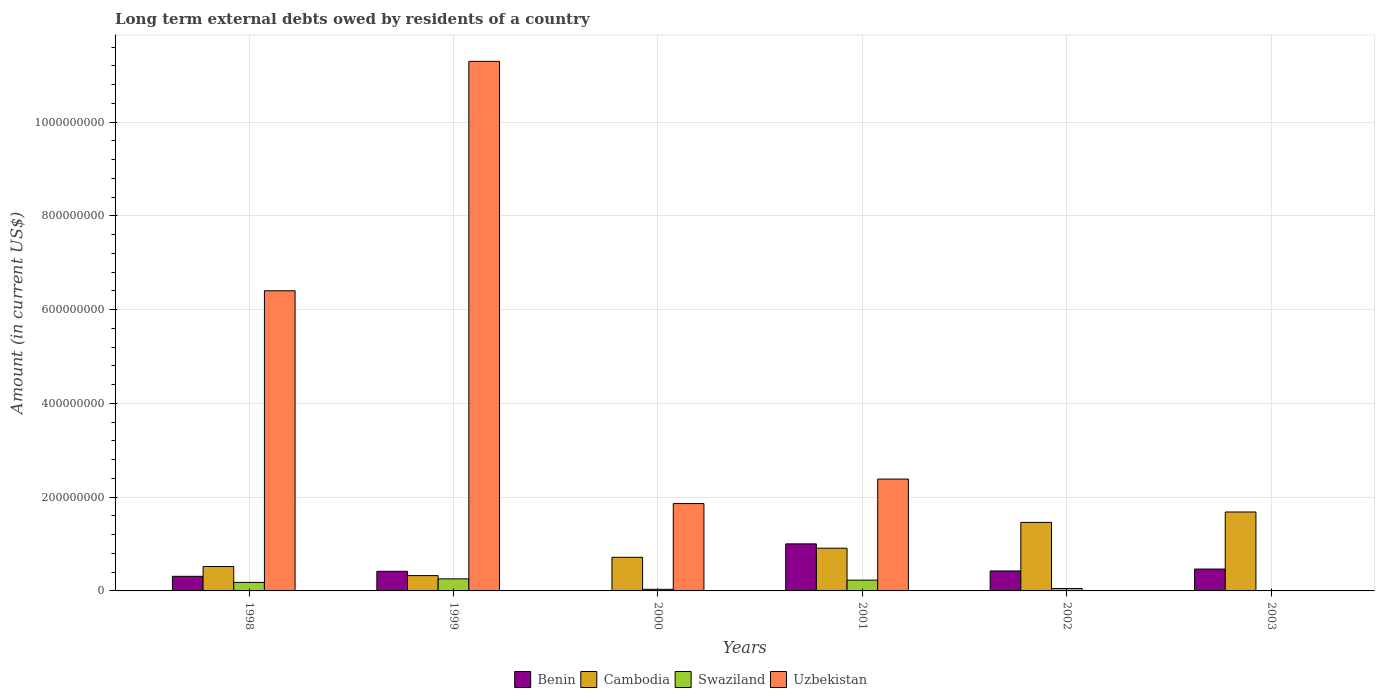How many bars are there on the 3rd tick from the right?
Make the answer very short. 4. What is the label of the 6th group of bars from the left?
Your response must be concise. 2003. Across all years, what is the maximum amount of long-term external debts owed by residents in Uzbekistan?
Your answer should be very brief. 1.13e+09. In which year was the amount of long-term external debts owed by residents in Swaziland maximum?
Your answer should be very brief. 1999. What is the total amount of long-term external debts owed by residents in Benin in the graph?
Offer a terse response. 2.63e+08. What is the difference between the amount of long-term external debts owed by residents in Swaziland in 1999 and that in 2001?
Offer a very short reply. 2.69e+06. What is the difference between the amount of long-term external debts owed by residents in Cambodia in 2000 and the amount of long-term external debts owed by residents in Swaziland in 1998?
Provide a short and direct response. 5.35e+07. What is the average amount of long-term external debts owed by residents in Swaziland per year?
Give a very brief answer. 1.26e+07. In the year 2001, what is the difference between the amount of long-term external debts owed by residents in Swaziland and amount of long-term external debts owed by residents in Benin?
Provide a succinct answer. -7.73e+07. What is the ratio of the amount of long-term external debts owed by residents in Benin in 2001 to that in 2003?
Your answer should be compact. 2.15. Is the difference between the amount of long-term external debts owed by residents in Swaziland in 1998 and 1999 greater than the difference between the amount of long-term external debts owed by residents in Benin in 1998 and 1999?
Keep it short and to the point. Yes. What is the difference between the highest and the second highest amount of long-term external debts owed by residents in Swaziland?
Ensure brevity in your answer.  2.69e+06. What is the difference between the highest and the lowest amount of long-term external debts owed by residents in Cambodia?
Give a very brief answer. 1.36e+08. Is it the case that in every year, the sum of the amount of long-term external debts owed by residents in Benin and amount of long-term external debts owed by residents in Uzbekistan is greater than the sum of amount of long-term external debts owed by residents in Cambodia and amount of long-term external debts owed by residents in Swaziland?
Keep it short and to the point. No. How many years are there in the graph?
Offer a terse response. 6. What is the difference between two consecutive major ticks on the Y-axis?
Ensure brevity in your answer.  2.00e+08. Does the graph contain grids?
Your answer should be very brief. Yes. Where does the legend appear in the graph?
Give a very brief answer. Bottom center. What is the title of the graph?
Offer a terse response. Long term external debts owed by residents of a country. What is the label or title of the X-axis?
Provide a succinct answer. Years. What is the label or title of the Y-axis?
Provide a short and direct response. Amount (in current US$). What is the Amount (in current US$) in Benin in 1998?
Make the answer very short. 3.11e+07. What is the Amount (in current US$) in Cambodia in 1998?
Your response must be concise. 5.20e+07. What is the Amount (in current US$) in Swaziland in 1998?
Provide a succinct answer. 1.82e+07. What is the Amount (in current US$) of Uzbekistan in 1998?
Your answer should be compact. 6.40e+08. What is the Amount (in current US$) of Benin in 1999?
Offer a very short reply. 4.18e+07. What is the Amount (in current US$) in Cambodia in 1999?
Your response must be concise. 3.27e+07. What is the Amount (in current US$) in Swaziland in 1999?
Ensure brevity in your answer.  2.57e+07. What is the Amount (in current US$) in Uzbekistan in 1999?
Keep it short and to the point. 1.13e+09. What is the Amount (in current US$) of Benin in 2000?
Your answer should be compact. 0. What is the Amount (in current US$) of Cambodia in 2000?
Give a very brief answer. 7.17e+07. What is the Amount (in current US$) in Swaziland in 2000?
Your response must be concise. 3.44e+06. What is the Amount (in current US$) in Uzbekistan in 2000?
Ensure brevity in your answer.  1.86e+08. What is the Amount (in current US$) in Benin in 2001?
Ensure brevity in your answer.  1.00e+08. What is the Amount (in current US$) in Cambodia in 2001?
Offer a terse response. 9.11e+07. What is the Amount (in current US$) of Swaziland in 2001?
Your answer should be compact. 2.30e+07. What is the Amount (in current US$) of Uzbekistan in 2001?
Provide a short and direct response. 2.39e+08. What is the Amount (in current US$) in Benin in 2002?
Your answer should be compact. 4.26e+07. What is the Amount (in current US$) in Cambodia in 2002?
Give a very brief answer. 1.46e+08. What is the Amount (in current US$) in Swaziland in 2002?
Your response must be concise. 5.19e+06. What is the Amount (in current US$) in Uzbekistan in 2002?
Provide a succinct answer. 0. What is the Amount (in current US$) of Benin in 2003?
Offer a very short reply. 4.66e+07. What is the Amount (in current US$) in Cambodia in 2003?
Ensure brevity in your answer.  1.68e+08. What is the Amount (in current US$) in Uzbekistan in 2003?
Offer a very short reply. 0. Across all years, what is the maximum Amount (in current US$) of Benin?
Offer a very short reply. 1.00e+08. Across all years, what is the maximum Amount (in current US$) in Cambodia?
Your answer should be compact. 1.68e+08. Across all years, what is the maximum Amount (in current US$) in Swaziland?
Offer a terse response. 2.57e+07. Across all years, what is the maximum Amount (in current US$) in Uzbekistan?
Offer a terse response. 1.13e+09. Across all years, what is the minimum Amount (in current US$) in Benin?
Your answer should be very brief. 0. Across all years, what is the minimum Amount (in current US$) of Cambodia?
Provide a succinct answer. 3.27e+07. Across all years, what is the minimum Amount (in current US$) of Uzbekistan?
Your answer should be compact. 0. What is the total Amount (in current US$) of Benin in the graph?
Provide a succinct answer. 2.63e+08. What is the total Amount (in current US$) of Cambodia in the graph?
Keep it short and to the point. 5.62e+08. What is the total Amount (in current US$) in Swaziland in the graph?
Provide a succinct answer. 7.56e+07. What is the total Amount (in current US$) of Uzbekistan in the graph?
Keep it short and to the point. 2.19e+09. What is the difference between the Amount (in current US$) of Benin in 1998 and that in 1999?
Ensure brevity in your answer.  -1.07e+07. What is the difference between the Amount (in current US$) in Cambodia in 1998 and that in 1999?
Offer a very short reply. 1.94e+07. What is the difference between the Amount (in current US$) of Swaziland in 1998 and that in 1999?
Your response must be concise. -7.54e+06. What is the difference between the Amount (in current US$) in Uzbekistan in 1998 and that in 1999?
Offer a very short reply. -4.89e+08. What is the difference between the Amount (in current US$) in Cambodia in 1998 and that in 2000?
Make the answer very short. -1.97e+07. What is the difference between the Amount (in current US$) of Swaziland in 1998 and that in 2000?
Give a very brief answer. 1.48e+07. What is the difference between the Amount (in current US$) in Uzbekistan in 1998 and that in 2000?
Make the answer very short. 4.54e+08. What is the difference between the Amount (in current US$) of Benin in 1998 and that in 2001?
Your answer should be very brief. -6.92e+07. What is the difference between the Amount (in current US$) of Cambodia in 1998 and that in 2001?
Your answer should be compact. -3.91e+07. What is the difference between the Amount (in current US$) of Swaziland in 1998 and that in 2001?
Offer a very short reply. -4.84e+06. What is the difference between the Amount (in current US$) in Uzbekistan in 1998 and that in 2001?
Offer a terse response. 4.02e+08. What is the difference between the Amount (in current US$) in Benin in 1998 and that in 2002?
Provide a short and direct response. -1.15e+07. What is the difference between the Amount (in current US$) in Cambodia in 1998 and that in 2002?
Provide a succinct answer. -9.41e+07. What is the difference between the Amount (in current US$) in Swaziland in 1998 and that in 2002?
Your answer should be very brief. 1.30e+07. What is the difference between the Amount (in current US$) in Benin in 1998 and that in 2003?
Keep it short and to the point. -1.55e+07. What is the difference between the Amount (in current US$) of Cambodia in 1998 and that in 2003?
Provide a short and direct response. -1.16e+08. What is the difference between the Amount (in current US$) of Cambodia in 1999 and that in 2000?
Provide a succinct answer. -3.91e+07. What is the difference between the Amount (in current US$) of Swaziland in 1999 and that in 2000?
Make the answer very short. 2.23e+07. What is the difference between the Amount (in current US$) in Uzbekistan in 1999 and that in 2000?
Ensure brevity in your answer.  9.43e+08. What is the difference between the Amount (in current US$) in Benin in 1999 and that in 2001?
Give a very brief answer. -5.86e+07. What is the difference between the Amount (in current US$) of Cambodia in 1999 and that in 2001?
Make the answer very short. -5.85e+07. What is the difference between the Amount (in current US$) of Swaziland in 1999 and that in 2001?
Your response must be concise. 2.69e+06. What is the difference between the Amount (in current US$) in Uzbekistan in 1999 and that in 2001?
Keep it short and to the point. 8.91e+08. What is the difference between the Amount (in current US$) of Benin in 1999 and that in 2002?
Keep it short and to the point. -8.07e+05. What is the difference between the Amount (in current US$) of Cambodia in 1999 and that in 2002?
Provide a short and direct response. -1.13e+08. What is the difference between the Amount (in current US$) of Swaziland in 1999 and that in 2002?
Provide a succinct answer. 2.06e+07. What is the difference between the Amount (in current US$) of Benin in 1999 and that in 2003?
Provide a short and direct response. -4.83e+06. What is the difference between the Amount (in current US$) in Cambodia in 1999 and that in 2003?
Your response must be concise. -1.36e+08. What is the difference between the Amount (in current US$) of Cambodia in 2000 and that in 2001?
Offer a very short reply. -1.94e+07. What is the difference between the Amount (in current US$) of Swaziland in 2000 and that in 2001?
Provide a succinct answer. -1.96e+07. What is the difference between the Amount (in current US$) in Uzbekistan in 2000 and that in 2001?
Give a very brief answer. -5.22e+07. What is the difference between the Amount (in current US$) of Cambodia in 2000 and that in 2002?
Keep it short and to the point. -7.44e+07. What is the difference between the Amount (in current US$) of Swaziland in 2000 and that in 2002?
Make the answer very short. -1.75e+06. What is the difference between the Amount (in current US$) of Cambodia in 2000 and that in 2003?
Your answer should be compact. -9.66e+07. What is the difference between the Amount (in current US$) in Benin in 2001 and that in 2002?
Offer a very short reply. 5.77e+07. What is the difference between the Amount (in current US$) in Cambodia in 2001 and that in 2002?
Make the answer very short. -5.50e+07. What is the difference between the Amount (in current US$) in Swaziland in 2001 and that in 2002?
Offer a terse response. 1.79e+07. What is the difference between the Amount (in current US$) of Benin in 2001 and that in 2003?
Provide a short and direct response. 5.37e+07. What is the difference between the Amount (in current US$) in Cambodia in 2001 and that in 2003?
Your response must be concise. -7.72e+07. What is the difference between the Amount (in current US$) of Benin in 2002 and that in 2003?
Ensure brevity in your answer.  -4.02e+06. What is the difference between the Amount (in current US$) of Cambodia in 2002 and that in 2003?
Provide a short and direct response. -2.22e+07. What is the difference between the Amount (in current US$) of Benin in 1998 and the Amount (in current US$) of Cambodia in 1999?
Your answer should be very brief. -1.53e+06. What is the difference between the Amount (in current US$) in Benin in 1998 and the Amount (in current US$) in Swaziland in 1999?
Ensure brevity in your answer.  5.39e+06. What is the difference between the Amount (in current US$) in Benin in 1998 and the Amount (in current US$) in Uzbekistan in 1999?
Offer a very short reply. -1.10e+09. What is the difference between the Amount (in current US$) of Cambodia in 1998 and the Amount (in current US$) of Swaziland in 1999?
Ensure brevity in your answer.  2.63e+07. What is the difference between the Amount (in current US$) in Cambodia in 1998 and the Amount (in current US$) in Uzbekistan in 1999?
Offer a terse response. -1.08e+09. What is the difference between the Amount (in current US$) of Swaziland in 1998 and the Amount (in current US$) of Uzbekistan in 1999?
Make the answer very short. -1.11e+09. What is the difference between the Amount (in current US$) of Benin in 1998 and the Amount (in current US$) of Cambodia in 2000?
Your answer should be very brief. -4.06e+07. What is the difference between the Amount (in current US$) in Benin in 1998 and the Amount (in current US$) in Swaziland in 2000?
Your answer should be compact. 2.77e+07. What is the difference between the Amount (in current US$) of Benin in 1998 and the Amount (in current US$) of Uzbekistan in 2000?
Give a very brief answer. -1.55e+08. What is the difference between the Amount (in current US$) of Cambodia in 1998 and the Amount (in current US$) of Swaziland in 2000?
Your answer should be very brief. 4.86e+07. What is the difference between the Amount (in current US$) in Cambodia in 1998 and the Amount (in current US$) in Uzbekistan in 2000?
Offer a very short reply. -1.34e+08. What is the difference between the Amount (in current US$) of Swaziland in 1998 and the Amount (in current US$) of Uzbekistan in 2000?
Your answer should be compact. -1.68e+08. What is the difference between the Amount (in current US$) of Benin in 1998 and the Amount (in current US$) of Cambodia in 2001?
Your response must be concise. -6.00e+07. What is the difference between the Amount (in current US$) in Benin in 1998 and the Amount (in current US$) in Swaziland in 2001?
Provide a succinct answer. 8.08e+06. What is the difference between the Amount (in current US$) of Benin in 1998 and the Amount (in current US$) of Uzbekistan in 2001?
Offer a terse response. -2.07e+08. What is the difference between the Amount (in current US$) of Cambodia in 1998 and the Amount (in current US$) of Swaziland in 2001?
Give a very brief answer. 2.90e+07. What is the difference between the Amount (in current US$) in Cambodia in 1998 and the Amount (in current US$) in Uzbekistan in 2001?
Ensure brevity in your answer.  -1.87e+08. What is the difference between the Amount (in current US$) of Swaziland in 1998 and the Amount (in current US$) of Uzbekistan in 2001?
Keep it short and to the point. -2.20e+08. What is the difference between the Amount (in current US$) of Benin in 1998 and the Amount (in current US$) of Cambodia in 2002?
Make the answer very short. -1.15e+08. What is the difference between the Amount (in current US$) in Benin in 1998 and the Amount (in current US$) in Swaziland in 2002?
Give a very brief answer. 2.59e+07. What is the difference between the Amount (in current US$) in Cambodia in 1998 and the Amount (in current US$) in Swaziland in 2002?
Your response must be concise. 4.68e+07. What is the difference between the Amount (in current US$) in Benin in 1998 and the Amount (in current US$) in Cambodia in 2003?
Give a very brief answer. -1.37e+08. What is the difference between the Amount (in current US$) in Benin in 1999 and the Amount (in current US$) in Cambodia in 2000?
Provide a succinct answer. -2.99e+07. What is the difference between the Amount (in current US$) in Benin in 1999 and the Amount (in current US$) in Swaziland in 2000?
Offer a terse response. 3.84e+07. What is the difference between the Amount (in current US$) of Benin in 1999 and the Amount (in current US$) of Uzbekistan in 2000?
Your response must be concise. -1.45e+08. What is the difference between the Amount (in current US$) of Cambodia in 1999 and the Amount (in current US$) of Swaziland in 2000?
Make the answer very short. 2.92e+07. What is the difference between the Amount (in current US$) in Cambodia in 1999 and the Amount (in current US$) in Uzbekistan in 2000?
Keep it short and to the point. -1.54e+08. What is the difference between the Amount (in current US$) in Swaziland in 1999 and the Amount (in current US$) in Uzbekistan in 2000?
Your answer should be compact. -1.61e+08. What is the difference between the Amount (in current US$) in Benin in 1999 and the Amount (in current US$) in Cambodia in 2001?
Ensure brevity in your answer.  -4.93e+07. What is the difference between the Amount (in current US$) of Benin in 1999 and the Amount (in current US$) of Swaziland in 2001?
Offer a very short reply. 1.88e+07. What is the difference between the Amount (in current US$) of Benin in 1999 and the Amount (in current US$) of Uzbekistan in 2001?
Your response must be concise. -1.97e+08. What is the difference between the Amount (in current US$) in Cambodia in 1999 and the Amount (in current US$) in Swaziland in 2001?
Provide a short and direct response. 9.62e+06. What is the difference between the Amount (in current US$) in Cambodia in 1999 and the Amount (in current US$) in Uzbekistan in 2001?
Your answer should be compact. -2.06e+08. What is the difference between the Amount (in current US$) in Swaziland in 1999 and the Amount (in current US$) in Uzbekistan in 2001?
Your answer should be compact. -2.13e+08. What is the difference between the Amount (in current US$) in Benin in 1999 and the Amount (in current US$) in Cambodia in 2002?
Your response must be concise. -1.04e+08. What is the difference between the Amount (in current US$) in Benin in 1999 and the Amount (in current US$) in Swaziland in 2002?
Give a very brief answer. 3.66e+07. What is the difference between the Amount (in current US$) of Cambodia in 1999 and the Amount (in current US$) of Swaziland in 2002?
Your answer should be compact. 2.75e+07. What is the difference between the Amount (in current US$) of Benin in 1999 and the Amount (in current US$) of Cambodia in 2003?
Offer a terse response. -1.27e+08. What is the difference between the Amount (in current US$) in Cambodia in 2000 and the Amount (in current US$) in Swaziland in 2001?
Provide a short and direct response. 4.87e+07. What is the difference between the Amount (in current US$) of Cambodia in 2000 and the Amount (in current US$) of Uzbekistan in 2001?
Provide a short and direct response. -1.67e+08. What is the difference between the Amount (in current US$) of Swaziland in 2000 and the Amount (in current US$) of Uzbekistan in 2001?
Ensure brevity in your answer.  -2.35e+08. What is the difference between the Amount (in current US$) in Cambodia in 2000 and the Amount (in current US$) in Swaziland in 2002?
Offer a very short reply. 6.66e+07. What is the difference between the Amount (in current US$) in Benin in 2001 and the Amount (in current US$) in Cambodia in 2002?
Your answer should be compact. -4.58e+07. What is the difference between the Amount (in current US$) in Benin in 2001 and the Amount (in current US$) in Swaziland in 2002?
Offer a very short reply. 9.52e+07. What is the difference between the Amount (in current US$) in Cambodia in 2001 and the Amount (in current US$) in Swaziland in 2002?
Ensure brevity in your answer.  8.60e+07. What is the difference between the Amount (in current US$) in Benin in 2001 and the Amount (in current US$) in Cambodia in 2003?
Ensure brevity in your answer.  -6.80e+07. What is the difference between the Amount (in current US$) of Benin in 2002 and the Amount (in current US$) of Cambodia in 2003?
Your response must be concise. -1.26e+08. What is the average Amount (in current US$) of Benin per year?
Your response must be concise. 4.38e+07. What is the average Amount (in current US$) of Cambodia per year?
Your answer should be compact. 9.37e+07. What is the average Amount (in current US$) of Swaziland per year?
Your response must be concise. 1.26e+07. What is the average Amount (in current US$) of Uzbekistan per year?
Keep it short and to the point. 3.66e+08. In the year 1998, what is the difference between the Amount (in current US$) in Benin and Amount (in current US$) in Cambodia?
Your response must be concise. -2.09e+07. In the year 1998, what is the difference between the Amount (in current US$) of Benin and Amount (in current US$) of Swaziland?
Provide a short and direct response. 1.29e+07. In the year 1998, what is the difference between the Amount (in current US$) in Benin and Amount (in current US$) in Uzbekistan?
Your answer should be very brief. -6.09e+08. In the year 1998, what is the difference between the Amount (in current US$) of Cambodia and Amount (in current US$) of Swaziland?
Provide a short and direct response. 3.38e+07. In the year 1998, what is the difference between the Amount (in current US$) in Cambodia and Amount (in current US$) in Uzbekistan?
Your answer should be compact. -5.88e+08. In the year 1998, what is the difference between the Amount (in current US$) in Swaziland and Amount (in current US$) in Uzbekistan?
Your response must be concise. -6.22e+08. In the year 1999, what is the difference between the Amount (in current US$) in Benin and Amount (in current US$) in Cambodia?
Offer a terse response. 9.14e+06. In the year 1999, what is the difference between the Amount (in current US$) of Benin and Amount (in current US$) of Swaziland?
Offer a terse response. 1.61e+07. In the year 1999, what is the difference between the Amount (in current US$) in Benin and Amount (in current US$) in Uzbekistan?
Make the answer very short. -1.09e+09. In the year 1999, what is the difference between the Amount (in current US$) of Cambodia and Amount (in current US$) of Swaziland?
Your response must be concise. 6.92e+06. In the year 1999, what is the difference between the Amount (in current US$) in Cambodia and Amount (in current US$) in Uzbekistan?
Provide a short and direct response. -1.10e+09. In the year 1999, what is the difference between the Amount (in current US$) of Swaziland and Amount (in current US$) of Uzbekistan?
Provide a succinct answer. -1.10e+09. In the year 2000, what is the difference between the Amount (in current US$) of Cambodia and Amount (in current US$) of Swaziland?
Provide a succinct answer. 6.83e+07. In the year 2000, what is the difference between the Amount (in current US$) of Cambodia and Amount (in current US$) of Uzbekistan?
Your answer should be compact. -1.15e+08. In the year 2000, what is the difference between the Amount (in current US$) of Swaziland and Amount (in current US$) of Uzbekistan?
Offer a very short reply. -1.83e+08. In the year 2001, what is the difference between the Amount (in current US$) in Benin and Amount (in current US$) in Cambodia?
Your answer should be very brief. 9.22e+06. In the year 2001, what is the difference between the Amount (in current US$) of Benin and Amount (in current US$) of Swaziland?
Your response must be concise. 7.73e+07. In the year 2001, what is the difference between the Amount (in current US$) of Benin and Amount (in current US$) of Uzbekistan?
Keep it short and to the point. -1.38e+08. In the year 2001, what is the difference between the Amount (in current US$) in Cambodia and Amount (in current US$) in Swaziland?
Offer a very short reply. 6.81e+07. In the year 2001, what is the difference between the Amount (in current US$) in Cambodia and Amount (in current US$) in Uzbekistan?
Offer a very short reply. -1.47e+08. In the year 2001, what is the difference between the Amount (in current US$) of Swaziland and Amount (in current US$) of Uzbekistan?
Make the answer very short. -2.16e+08. In the year 2002, what is the difference between the Amount (in current US$) of Benin and Amount (in current US$) of Cambodia?
Your answer should be very brief. -1.04e+08. In the year 2002, what is the difference between the Amount (in current US$) in Benin and Amount (in current US$) in Swaziland?
Give a very brief answer. 3.74e+07. In the year 2002, what is the difference between the Amount (in current US$) of Cambodia and Amount (in current US$) of Swaziland?
Your answer should be compact. 1.41e+08. In the year 2003, what is the difference between the Amount (in current US$) of Benin and Amount (in current US$) of Cambodia?
Make the answer very short. -1.22e+08. What is the ratio of the Amount (in current US$) in Benin in 1998 to that in 1999?
Offer a terse response. 0.74. What is the ratio of the Amount (in current US$) of Cambodia in 1998 to that in 1999?
Your response must be concise. 1.59. What is the ratio of the Amount (in current US$) in Swaziland in 1998 to that in 1999?
Keep it short and to the point. 0.71. What is the ratio of the Amount (in current US$) of Uzbekistan in 1998 to that in 1999?
Provide a short and direct response. 0.57. What is the ratio of the Amount (in current US$) of Cambodia in 1998 to that in 2000?
Offer a very short reply. 0.73. What is the ratio of the Amount (in current US$) of Swaziland in 1998 to that in 2000?
Keep it short and to the point. 5.3. What is the ratio of the Amount (in current US$) of Uzbekistan in 1998 to that in 2000?
Keep it short and to the point. 3.44. What is the ratio of the Amount (in current US$) in Benin in 1998 to that in 2001?
Your response must be concise. 0.31. What is the ratio of the Amount (in current US$) of Cambodia in 1998 to that in 2001?
Provide a succinct answer. 0.57. What is the ratio of the Amount (in current US$) in Swaziland in 1998 to that in 2001?
Make the answer very short. 0.79. What is the ratio of the Amount (in current US$) in Uzbekistan in 1998 to that in 2001?
Offer a very short reply. 2.68. What is the ratio of the Amount (in current US$) of Benin in 1998 to that in 2002?
Your answer should be very brief. 0.73. What is the ratio of the Amount (in current US$) in Cambodia in 1998 to that in 2002?
Your response must be concise. 0.36. What is the ratio of the Amount (in current US$) in Swaziland in 1998 to that in 2002?
Ensure brevity in your answer.  3.51. What is the ratio of the Amount (in current US$) of Benin in 1998 to that in 2003?
Make the answer very short. 0.67. What is the ratio of the Amount (in current US$) in Cambodia in 1998 to that in 2003?
Your answer should be very brief. 0.31. What is the ratio of the Amount (in current US$) in Cambodia in 1999 to that in 2000?
Offer a terse response. 0.46. What is the ratio of the Amount (in current US$) in Swaziland in 1999 to that in 2000?
Your answer should be very brief. 7.49. What is the ratio of the Amount (in current US$) in Uzbekistan in 1999 to that in 2000?
Your response must be concise. 6.06. What is the ratio of the Amount (in current US$) of Benin in 1999 to that in 2001?
Offer a terse response. 0.42. What is the ratio of the Amount (in current US$) in Cambodia in 1999 to that in 2001?
Make the answer very short. 0.36. What is the ratio of the Amount (in current US$) in Swaziland in 1999 to that in 2001?
Ensure brevity in your answer.  1.12. What is the ratio of the Amount (in current US$) in Uzbekistan in 1999 to that in 2001?
Offer a terse response. 4.73. What is the ratio of the Amount (in current US$) of Benin in 1999 to that in 2002?
Make the answer very short. 0.98. What is the ratio of the Amount (in current US$) in Cambodia in 1999 to that in 2002?
Ensure brevity in your answer.  0.22. What is the ratio of the Amount (in current US$) in Swaziland in 1999 to that in 2002?
Give a very brief answer. 4.96. What is the ratio of the Amount (in current US$) of Benin in 1999 to that in 2003?
Keep it short and to the point. 0.9. What is the ratio of the Amount (in current US$) in Cambodia in 1999 to that in 2003?
Your answer should be compact. 0.19. What is the ratio of the Amount (in current US$) of Cambodia in 2000 to that in 2001?
Offer a very short reply. 0.79. What is the ratio of the Amount (in current US$) in Swaziland in 2000 to that in 2001?
Your response must be concise. 0.15. What is the ratio of the Amount (in current US$) of Uzbekistan in 2000 to that in 2001?
Offer a terse response. 0.78. What is the ratio of the Amount (in current US$) in Cambodia in 2000 to that in 2002?
Offer a very short reply. 0.49. What is the ratio of the Amount (in current US$) in Swaziland in 2000 to that in 2002?
Your answer should be very brief. 0.66. What is the ratio of the Amount (in current US$) in Cambodia in 2000 to that in 2003?
Offer a terse response. 0.43. What is the ratio of the Amount (in current US$) in Benin in 2001 to that in 2002?
Provide a short and direct response. 2.36. What is the ratio of the Amount (in current US$) of Cambodia in 2001 to that in 2002?
Provide a succinct answer. 0.62. What is the ratio of the Amount (in current US$) in Swaziland in 2001 to that in 2002?
Give a very brief answer. 4.44. What is the ratio of the Amount (in current US$) of Benin in 2001 to that in 2003?
Offer a terse response. 2.15. What is the ratio of the Amount (in current US$) in Cambodia in 2001 to that in 2003?
Give a very brief answer. 0.54. What is the ratio of the Amount (in current US$) of Benin in 2002 to that in 2003?
Your response must be concise. 0.91. What is the ratio of the Amount (in current US$) in Cambodia in 2002 to that in 2003?
Ensure brevity in your answer.  0.87. What is the difference between the highest and the second highest Amount (in current US$) in Benin?
Keep it short and to the point. 5.37e+07. What is the difference between the highest and the second highest Amount (in current US$) of Cambodia?
Give a very brief answer. 2.22e+07. What is the difference between the highest and the second highest Amount (in current US$) in Swaziland?
Give a very brief answer. 2.69e+06. What is the difference between the highest and the second highest Amount (in current US$) in Uzbekistan?
Ensure brevity in your answer.  4.89e+08. What is the difference between the highest and the lowest Amount (in current US$) in Benin?
Provide a succinct answer. 1.00e+08. What is the difference between the highest and the lowest Amount (in current US$) of Cambodia?
Offer a very short reply. 1.36e+08. What is the difference between the highest and the lowest Amount (in current US$) in Swaziland?
Provide a succinct answer. 2.57e+07. What is the difference between the highest and the lowest Amount (in current US$) of Uzbekistan?
Your answer should be compact. 1.13e+09. 